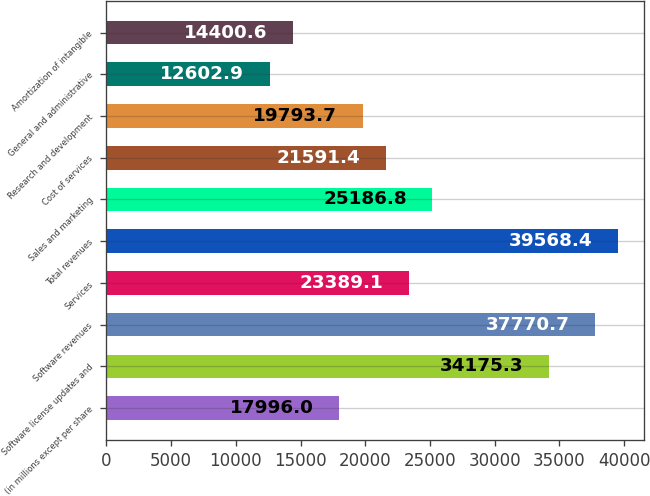<chart> <loc_0><loc_0><loc_500><loc_500><bar_chart><fcel>(in millions except per share<fcel>Software license updates and<fcel>Software revenues<fcel>Services<fcel>Total revenues<fcel>Sales and marketing<fcel>Cost of services<fcel>Research and development<fcel>General and administrative<fcel>Amortization of intangible<nl><fcel>17996<fcel>34175.3<fcel>37770.7<fcel>23389.1<fcel>39568.4<fcel>25186.8<fcel>21591.4<fcel>19793.7<fcel>12602.9<fcel>14400.6<nl></chart> 